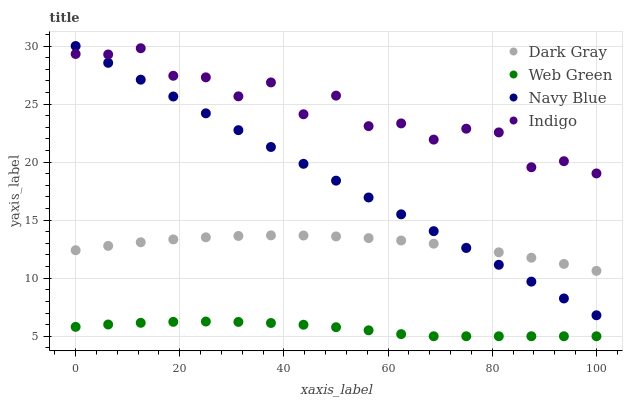Does Web Green have the minimum area under the curve?
Answer yes or no. Yes. Does Indigo have the maximum area under the curve?
Answer yes or no. Yes. Does Navy Blue have the minimum area under the curve?
Answer yes or no. No. Does Navy Blue have the maximum area under the curve?
Answer yes or no. No. Is Navy Blue the smoothest?
Answer yes or no. Yes. Is Indigo the roughest?
Answer yes or no. Yes. Is Indigo the smoothest?
Answer yes or no. No. Is Navy Blue the roughest?
Answer yes or no. No. Does Web Green have the lowest value?
Answer yes or no. Yes. Does Navy Blue have the lowest value?
Answer yes or no. No. Does Navy Blue have the highest value?
Answer yes or no. Yes. Does Indigo have the highest value?
Answer yes or no. No. Is Web Green less than Navy Blue?
Answer yes or no. Yes. Is Navy Blue greater than Web Green?
Answer yes or no. Yes. Does Navy Blue intersect Indigo?
Answer yes or no. Yes. Is Navy Blue less than Indigo?
Answer yes or no. No. Is Navy Blue greater than Indigo?
Answer yes or no. No. Does Web Green intersect Navy Blue?
Answer yes or no. No. 